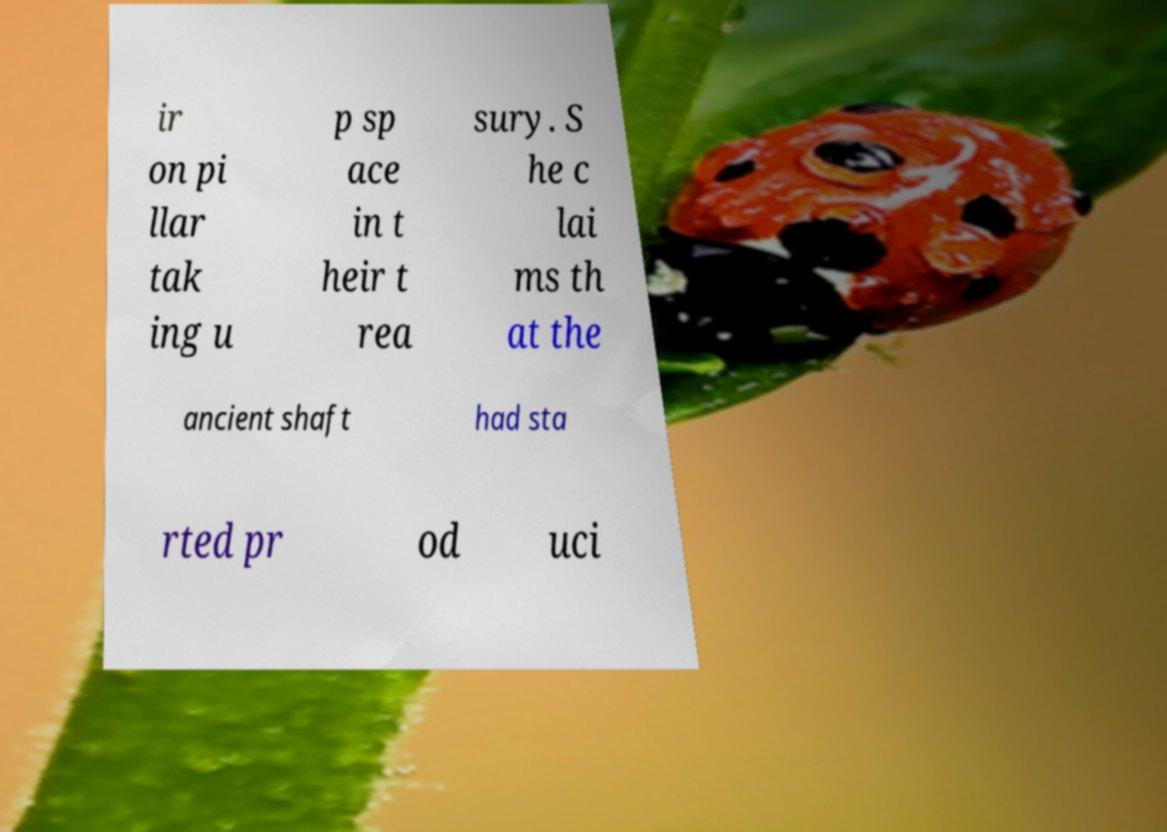Please identify and transcribe the text found in this image. ir on pi llar tak ing u p sp ace in t heir t rea sury. S he c lai ms th at the ancient shaft had sta rted pr od uci 